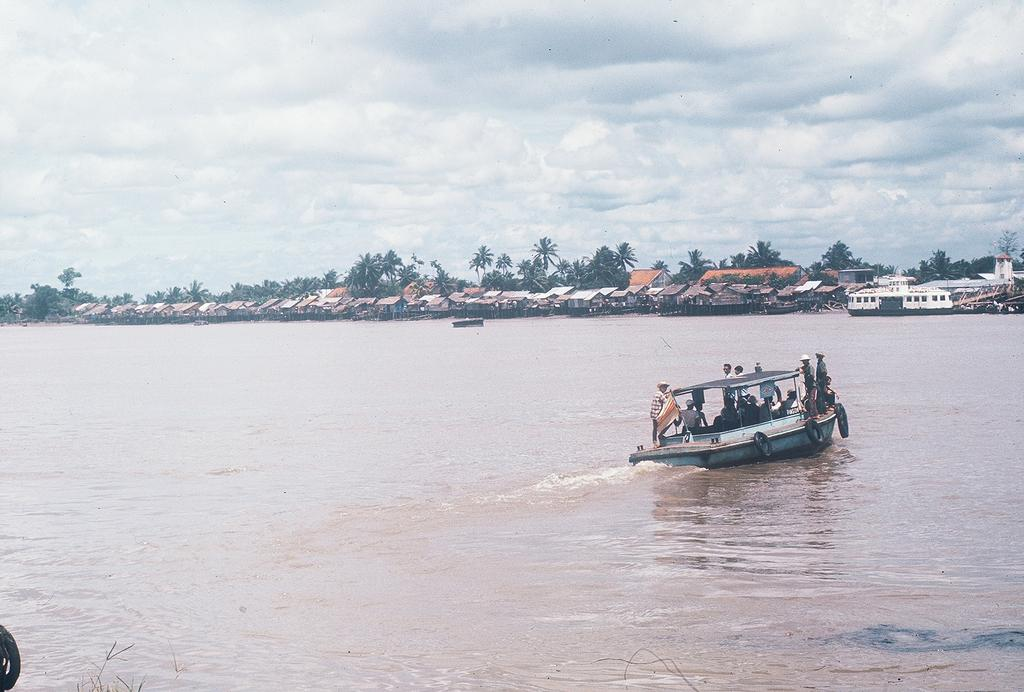What is happening in the water in the image? There are boats on water in the image. Are there any people on the boats? Yes, there are people on at least one of the boats. What else can be seen in the image besides the boats and water? There are houses, trees, and the sky visible in the image. Where is the map located in the image? There is no map present in the image. Can you tell me how many dogs are visible in the image? There are no dogs present in the image. 